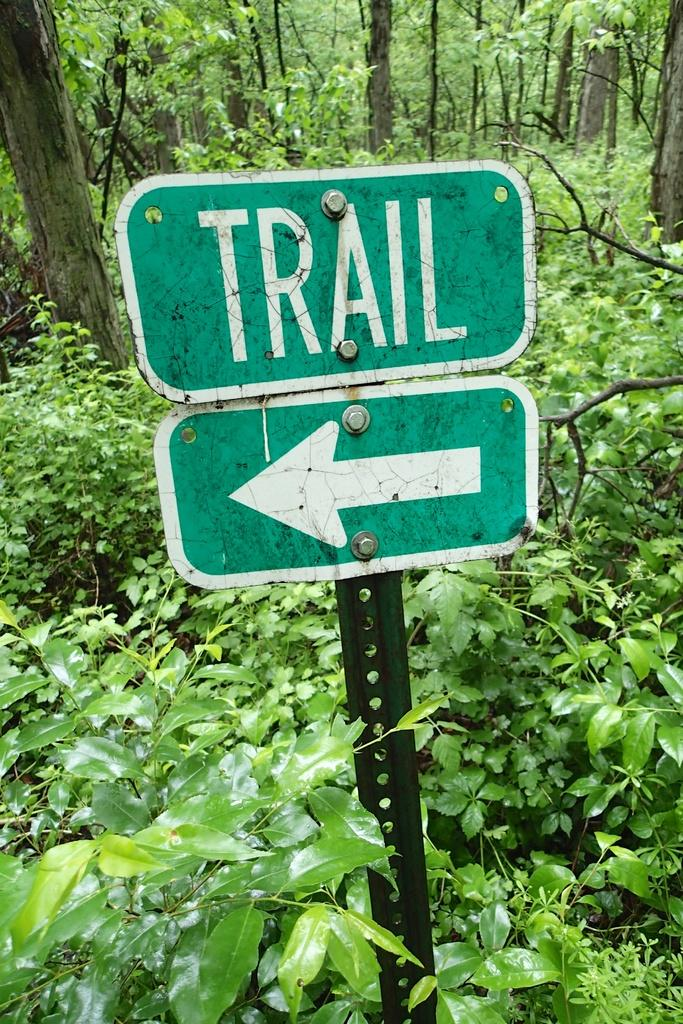Provide a one-sentence caption for the provided image. A sign that says Trail and points to the left. 